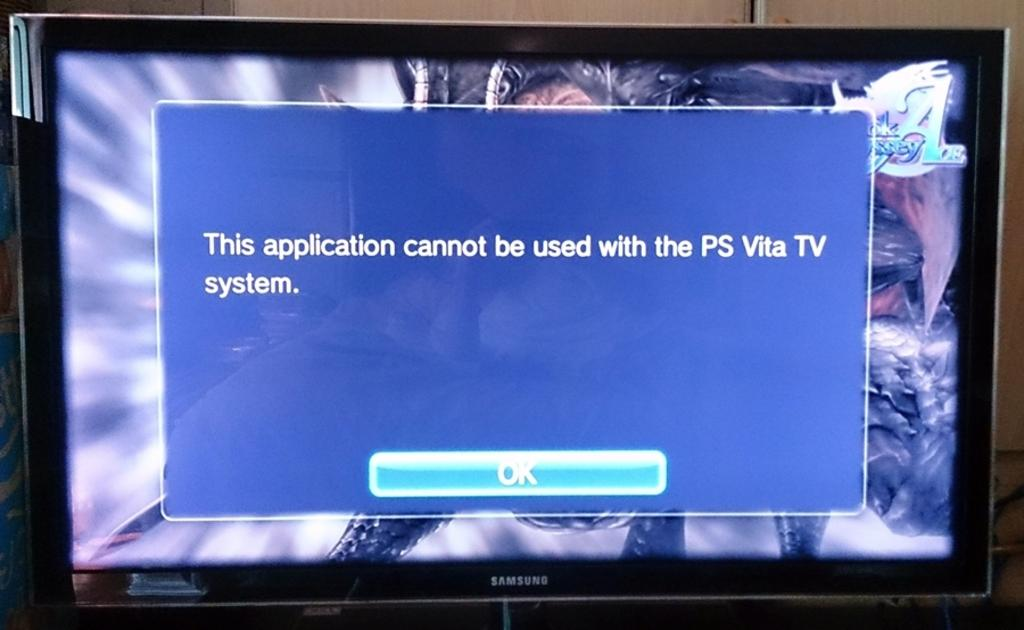<image>
Write a terse but informative summary of the picture. a message on a screen that an app cannot be used 